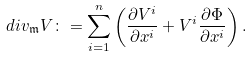Convert formula to latex. <formula><loc_0><loc_0><loc_500><loc_500>d i v _ { \mathfrak { m } } V \colon = \sum _ { i = 1 } ^ { n } \left ( \frac { \partial V ^ { i } } { \partial x ^ { i } } + V ^ { i } \frac { \partial \Phi } { \partial x ^ { i } } \right ) .</formula> 